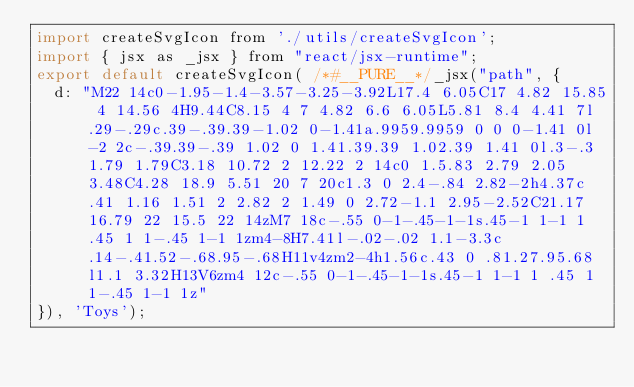Convert code to text. <code><loc_0><loc_0><loc_500><loc_500><_JavaScript_>import createSvgIcon from './utils/createSvgIcon';
import { jsx as _jsx } from "react/jsx-runtime";
export default createSvgIcon( /*#__PURE__*/_jsx("path", {
  d: "M22 14c0-1.95-1.4-3.57-3.25-3.92L17.4 6.05C17 4.82 15.85 4 14.56 4H9.44C8.15 4 7 4.82 6.6 6.05L5.81 8.4 4.41 7l.29-.29c.39-.39.39-1.02 0-1.41a.9959.9959 0 0 0-1.41 0l-2 2c-.39.39-.39 1.02 0 1.41.39.39 1.02.39 1.41 0l.3-.3 1.79 1.79C3.18 10.72 2 12.22 2 14c0 1.5.83 2.79 2.05 3.48C4.28 18.9 5.51 20 7 20c1.3 0 2.4-.84 2.82-2h4.37c.41 1.16 1.51 2 2.82 2 1.49 0 2.72-1.1 2.95-2.52C21.17 16.79 22 15.5 22 14zM7 18c-.55 0-1-.45-1-1s.45-1 1-1 1 .45 1 1-.45 1-1 1zm4-8H7.41l-.02-.02 1.1-3.3c.14-.41.52-.68.95-.68H11v4zm2-4h1.56c.43 0 .81.27.95.68l1.1 3.32H13V6zm4 12c-.55 0-1-.45-1-1s.45-1 1-1 1 .45 1 1-.45 1-1 1z"
}), 'Toys');</code> 